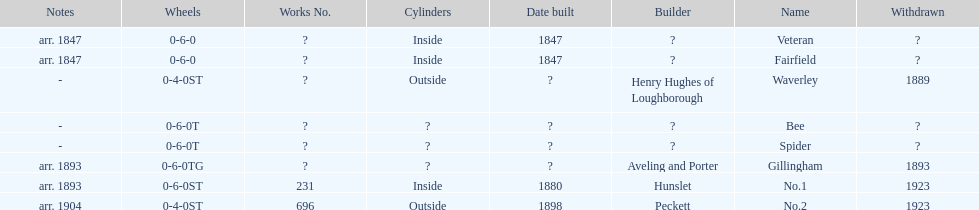What name comes next fairfield? Waverley. 